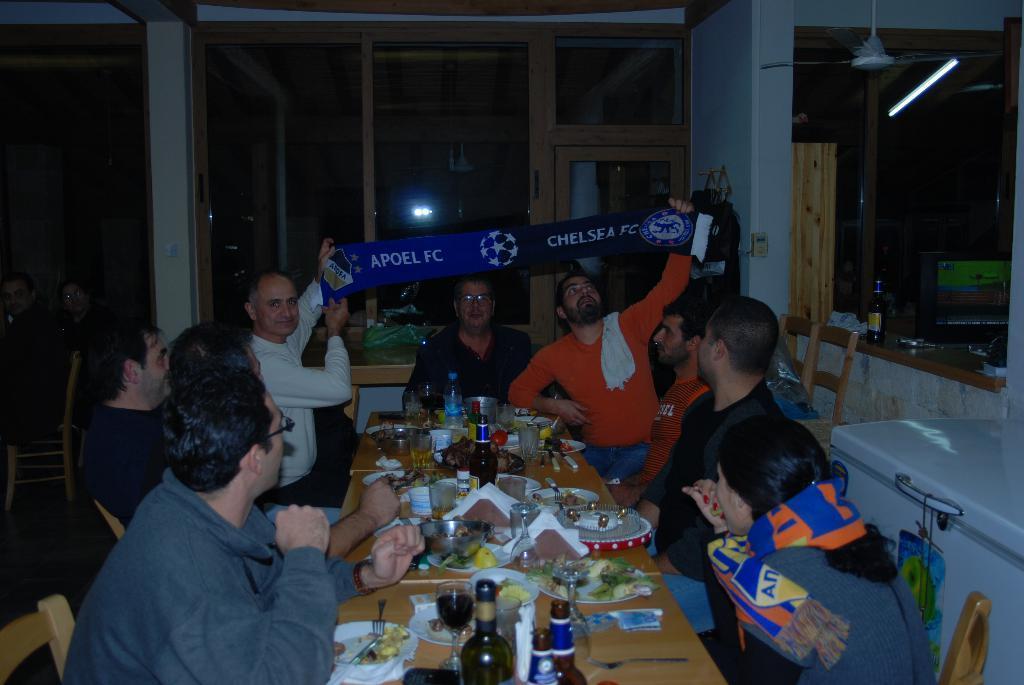Describe this image in one or two sentences. In this picture there are a group of people sitting and holding a banner and they have a table in front of them with wine bottles and food 